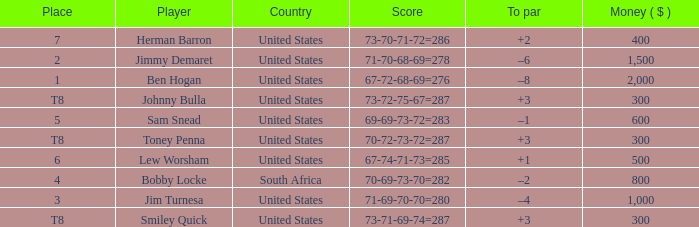What is the To par of the 4 Place Player? –2. 